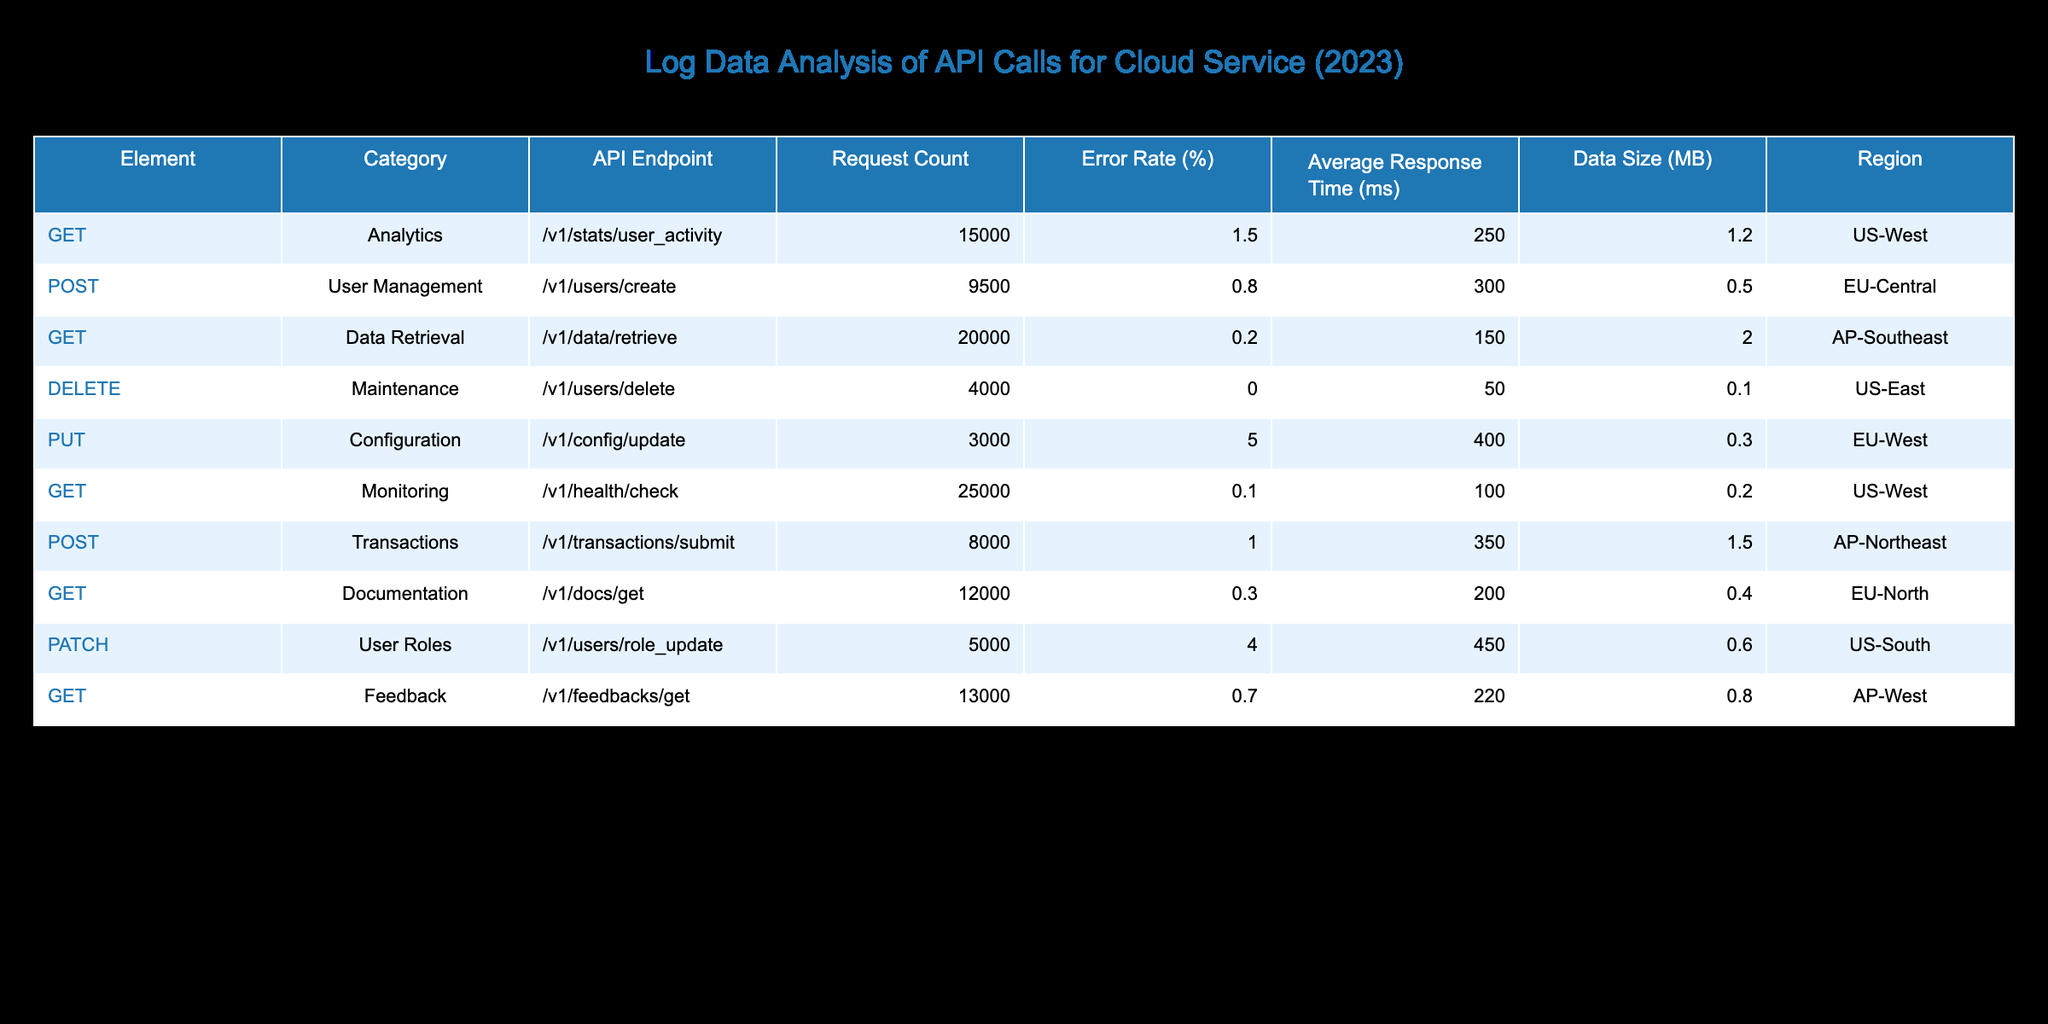What is the API endpoint with the highest request count? The request counts for the API endpoints are: 15000, 9500, 20000, 4000, 3000, 25000, 8000, 12000, 5000, and 13000. The highest is 25000 for the endpoint /v1/health/check.
Answer: /v1/health/check What is the average response time for the GET requests? The average response times for the GET requests are: 250, 150, 100, 200, and 220 ms. To find the average, sum these values (250 + 150 + 100 + 200 + 220 = 920) and divide by the number of GET requests (5), resulting in an average Response Time = 920/5 = 184 ms.
Answer: 184 ms Is the error rate for the DELETE endpoint greater than 1%? The error rate for the DELETE endpoint (/v1/users/delete) is listed as 0.0%, which is not greater than 1%.
Answer: No Which region has the highest average response time? The average response times for each region are as follows: US-West: 250 ms, EU-Central: 300 ms, AP-Southeast: 150 ms, US-East: 50 ms, EU-West: 400 ms, AP-Northeast: 350 ms, EU-North: 200 ms, US-South: 450 ms, and AP-West: 220 ms. The highest is 450 ms from the US-South region.
Answer: US-South How many total requests were made across all API endpoints? Total requests can be calculated by summing the Request Counts: 15000 + 9500 + 20000 + 4000 + 3000 + 25000 + 8000 + 12000 + 5000 + 13000 = 104500 total requests.
Answer: 104500 requests Which API endpoint has the lowest error rate? The error rates for all endpoints are 1.5%, 0.8%, 0.2%, 0.0%, 5.0%, 0.1%, 1.0%, 0.3%, 4.0%, and 0.7%. The lowest error rate is 0.0% from the DELETE endpoint (/v1/users/delete).
Answer: /v1/users/delete What is the average data size for POST requests? The data sizes for POST requests are: 0.5 MB for /v1/users/create and 1.5 MB for /v1/transactions/submit. The average is calculated by (0.5 + 1.5) / 2 = 1.0 MB.
Answer: 1.0 MB Does the PUT request have an average response time that exceeds 350 ms? The average response time for the PUT request (/v1/config/update) is 400 ms, which does exceed 350 ms.
Answer: Yes Which category has the maximum request count, and what is the count? The categories and their request counts are: Analytics (15000), User Management (9500), Data Retrieval (20000), Maintenance (4000), Configuration (3000), Monitoring (25000), Transactions (8000), Documentation (12000), User Roles (5000), Feedback (13000). The category with the maximum request count is Monitoring with 25000 requests.
Answer: Monitoring, 25000 requests 